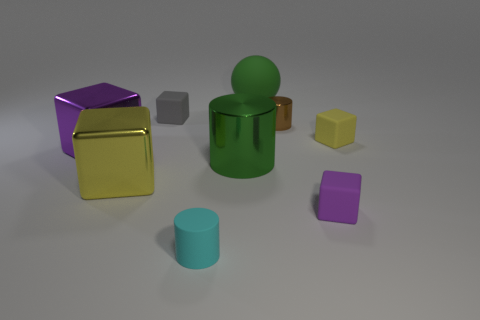Could you describe the mood or atmosphere depicted in this image? The image has a calm and controlled atmosphere. The presence of cool colors such as the cyan of the cylinder and the evenly diffused light conveys a serene, almost clinical impression, devoid of any chaotic elements. 